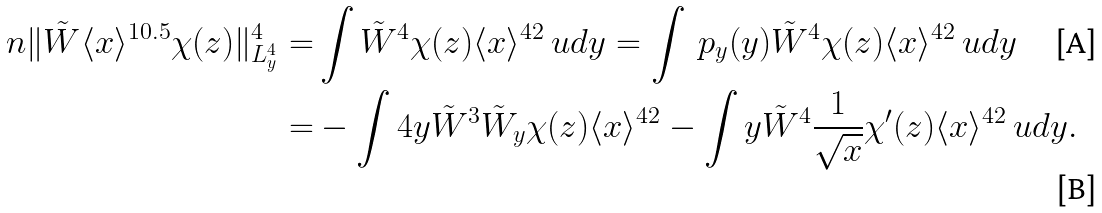Convert formula to latex. <formula><loc_0><loc_0><loc_500><loc_500>\ n \| \tilde { W } \langle x \rangle ^ { 1 0 . 5 } \chi ( z ) \| _ { L ^ { 4 } _ { y } } ^ { 4 } = & \int \tilde { W } ^ { 4 } \chi ( z ) \langle x \rangle ^ { 4 2 } \ u d y = \int \ p _ { y } ( y ) \tilde { W } ^ { 4 } \chi ( z ) \langle x \rangle ^ { 4 2 } \ u d y \\ = & - \int 4 y \tilde { W } ^ { 3 } \tilde { W } _ { y } \chi ( z ) \langle x \rangle ^ { 4 2 } - \int y \tilde { W } ^ { 4 } \frac { 1 } { \sqrt { x } } \chi ^ { \prime } ( z ) \langle x \rangle ^ { 4 2 } \ u d y .</formula> 